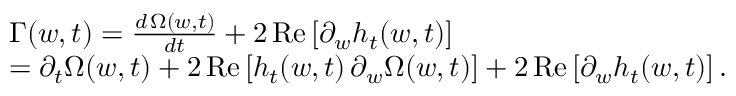Convert formula to latex. <formula><loc_0><loc_0><loc_500><loc_500>\begin{array} { r l } & { \Gamma ( w , t ) = \frac { d \, { \Omega } ( w , t ) } { d t } + 2 \, R e \left [ \partial _ { w } h _ { t } ( w , t ) \right ] } \\ & { = \partial _ { t } \Omega ( w , t ) + 2 \, R e \left [ h _ { t } ( w , t ) \, \partial _ { w } \Omega ( w , t ) \right ] + 2 \, R e \left [ \partial _ { w } h _ { t } ( w , t ) \right ] . } \end{array}</formula> 